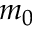<formula> <loc_0><loc_0><loc_500><loc_500>m _ { 0 }</formula> 